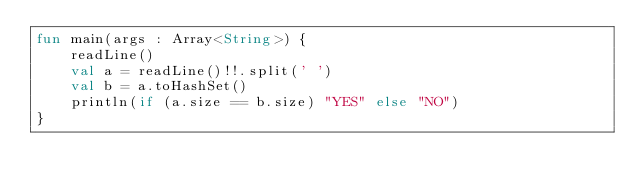<code> <loc_0><loc_0><loc_500><loc_500><_Kotlin_>fun main(args : Array<String>) {
    readLine()
    val a = readLine()!!.split(' ')
    val b = a.toHashSet()
    println(if (a.size == b.size) "YES" else "NO")
}
</code> 